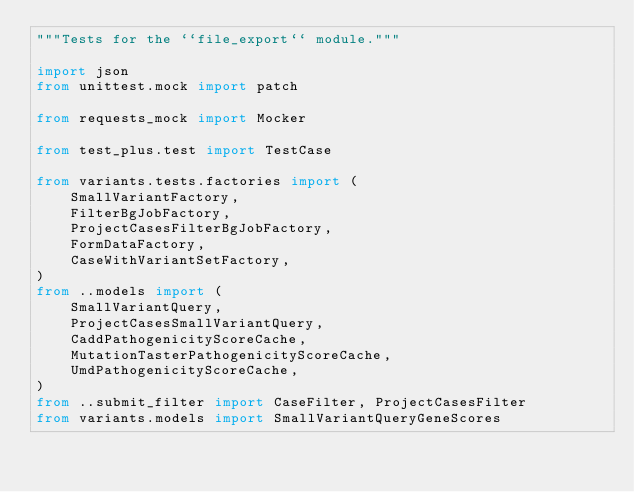<code> <loc_0><loc_0><loc_500><loc_500><_Python_>"""Tests for the ``file_export`` module."""

import json
from unittest.mock import patch

from requests_mock import Mocker

from test_plus.test import TestCase

from variants.tests.factories import (
    SmallVariantFactory,
    FilterBgJobFactory,
    ProjectCasesFilterBgJobFactory,
    FormDataFactory,
    CaseWithVariantSetFactory,
)
from ..models import (
    SmallVariantQuery,
    ProjectCasesSmallVariantQuery,
    CaddPathogenicityScoreCache,
    MutationTasterPathogenicityScoreCache,
    UmdPathogenicityScoreCache,
)
from ..submit_filter import CaseFilter, ProjectCasesFilter
from variants.models import SmallVariantQueryGeneScores</code> 